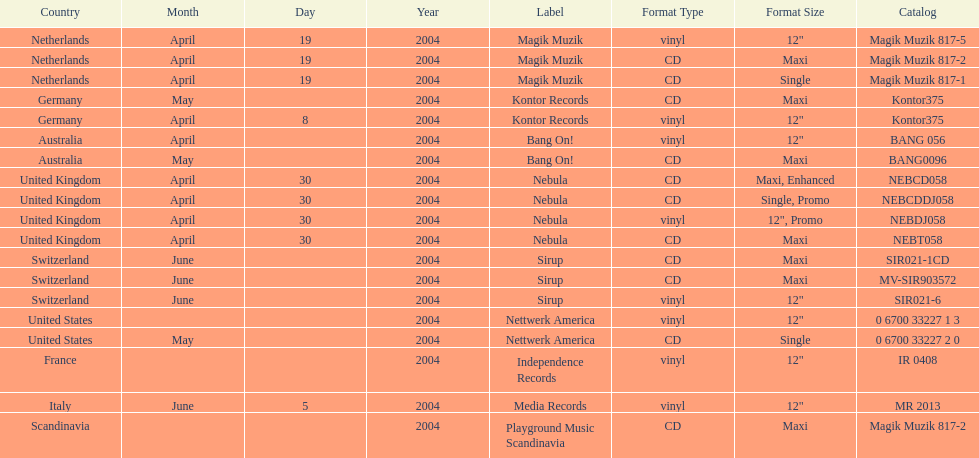Parse the full table. {'header': ['Country', 'Month', 'Day', 'Year', 'Label', 'Format Type', 'Format Size', 'Catalog'], 'rows': [['Netherlands', 'April', '19', '2004', 'Magik Muzik', 'vinyl', '12"', 'Magik Muzik 817-5'], ['Netherlands', 'April', '19', '2004', 'Magik Muzik', 'CD', 'Maxi', 'Magik Muzik 817-2'], ['Netherlands', 'April', '19', '2004', 'Magik Muzik', 'CD', 'Single', 'Magik Muzik 817-1'], ['Germany', 'May', '', '2004', 'Kontor Records', 'CD', 'Maxi', 'Kontor375'], ['Germany', 'April', '8', '2004', 'Kontor Records', 'vinyl', '12"', 'Kontor375'], ['Australia', 'April', '', '2004', 'Bang On!', 'vinyl', '12"', 'BANG 056'], ['Australia', 'May', '', '2004', 'Bang On!', 'CD', 'Maxi', 'BANG0096'], ['United Kingdom', 'April', '30', '2004', 'Nebula', 'CD', 'Maxi, Enhanced', 'NEBCD058'], ['United Kingdom', 'April', '30', '2004', 'Nebula', 'CD', 'Single, Promo', 'NEBCDDJ058'], ['United Kingdom', 'April', '30', '2004', 'Nebula', 'vinyl', '12", Promo', 'NEBDJ058'], ['United Kingdom', 'April', '30', '2004', 'Nebula', 'CD', 'Maxi', 'NEBT058'], ['Switzerland', 'June', '', '2004', 'Sirup', 'CD', 'Maxi', 'SIR021-1CD'], ['Switzerland', 'June', '', '2004', 'Sirup', 'CD', 'Maxi', 'MV-SIR903572'], ['Switzerland', 'June', '', '2004', 'Sirup', 'vinyl', '12"', 'SIR021-6'], ['United States', '', '', '2004', 'Nettwerk America', 'vinyl', '12"', '0 6700 33227 1 3'], ['United States', 'May', '', '2004', 'Nettwerk America', 'CD', 'Single', '0 6700 33227 2 0'], ['France', '', '', '2004', 'Independence Records', 'vinyl', '12"', 'IR 0408'], ['Italy', 'June', '5', '2004', 'Media Records', 'vinyl', '12"', 'MR 2013'], ['Scandinavia', '', '', '2004', 'Playground Music Scandinavia', 'CD', 'Maxi', 'Magik Muzik 817-2']]} How many catalogs were released? 19. 